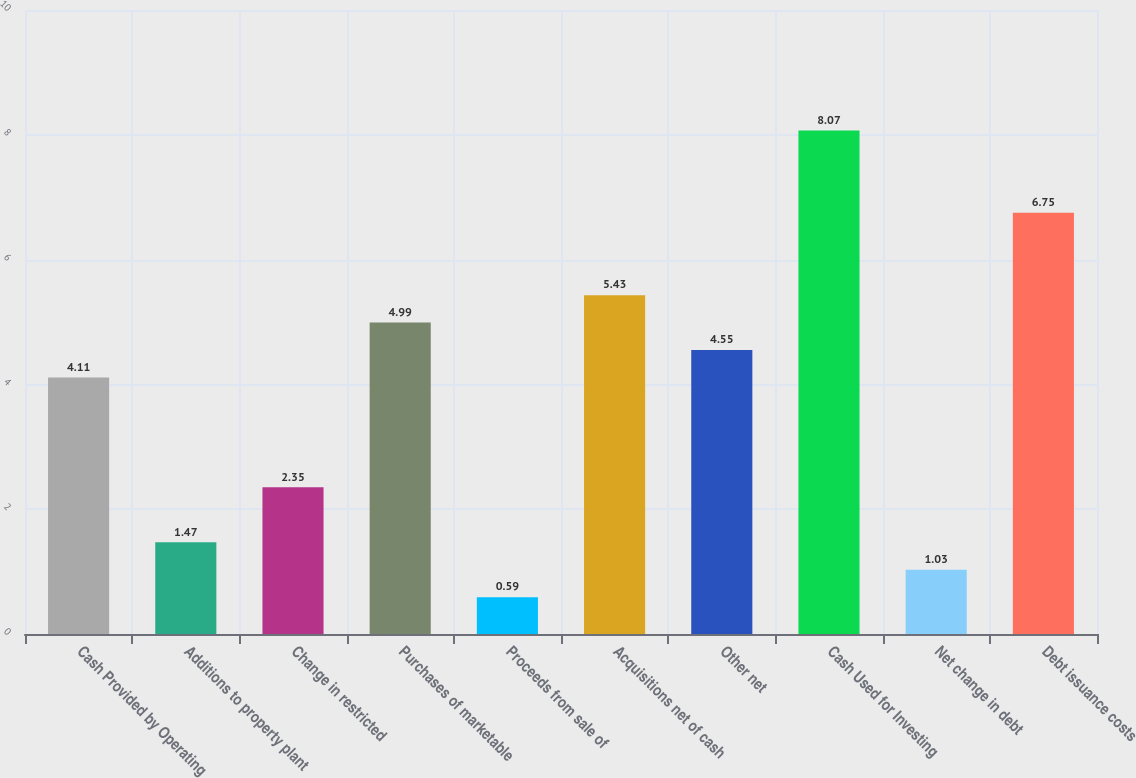<chart> <loc_0><loc_0><loc_500><loc_500><bar_chart><fcel>Cash Provided by Operating<fcel>Additions to property plant<fcel>Change in restricted<fcel>Purchases of marketable<fcel>Proceeds from sale of<fcel>Acquisitions net of cash<fcel>Other net<fcel>Cash Used for Investing<fcel>Net change in debt<fcel>Debt issuance costs<nl><fcel>4.11<fcel>1.47<fcel>2.35<fcel>4.99<fcel>0.59<fcel>5.43<fcel>4.55<fcel>8.07<fcel>1.03<fcel>6.75<nl></chart> 